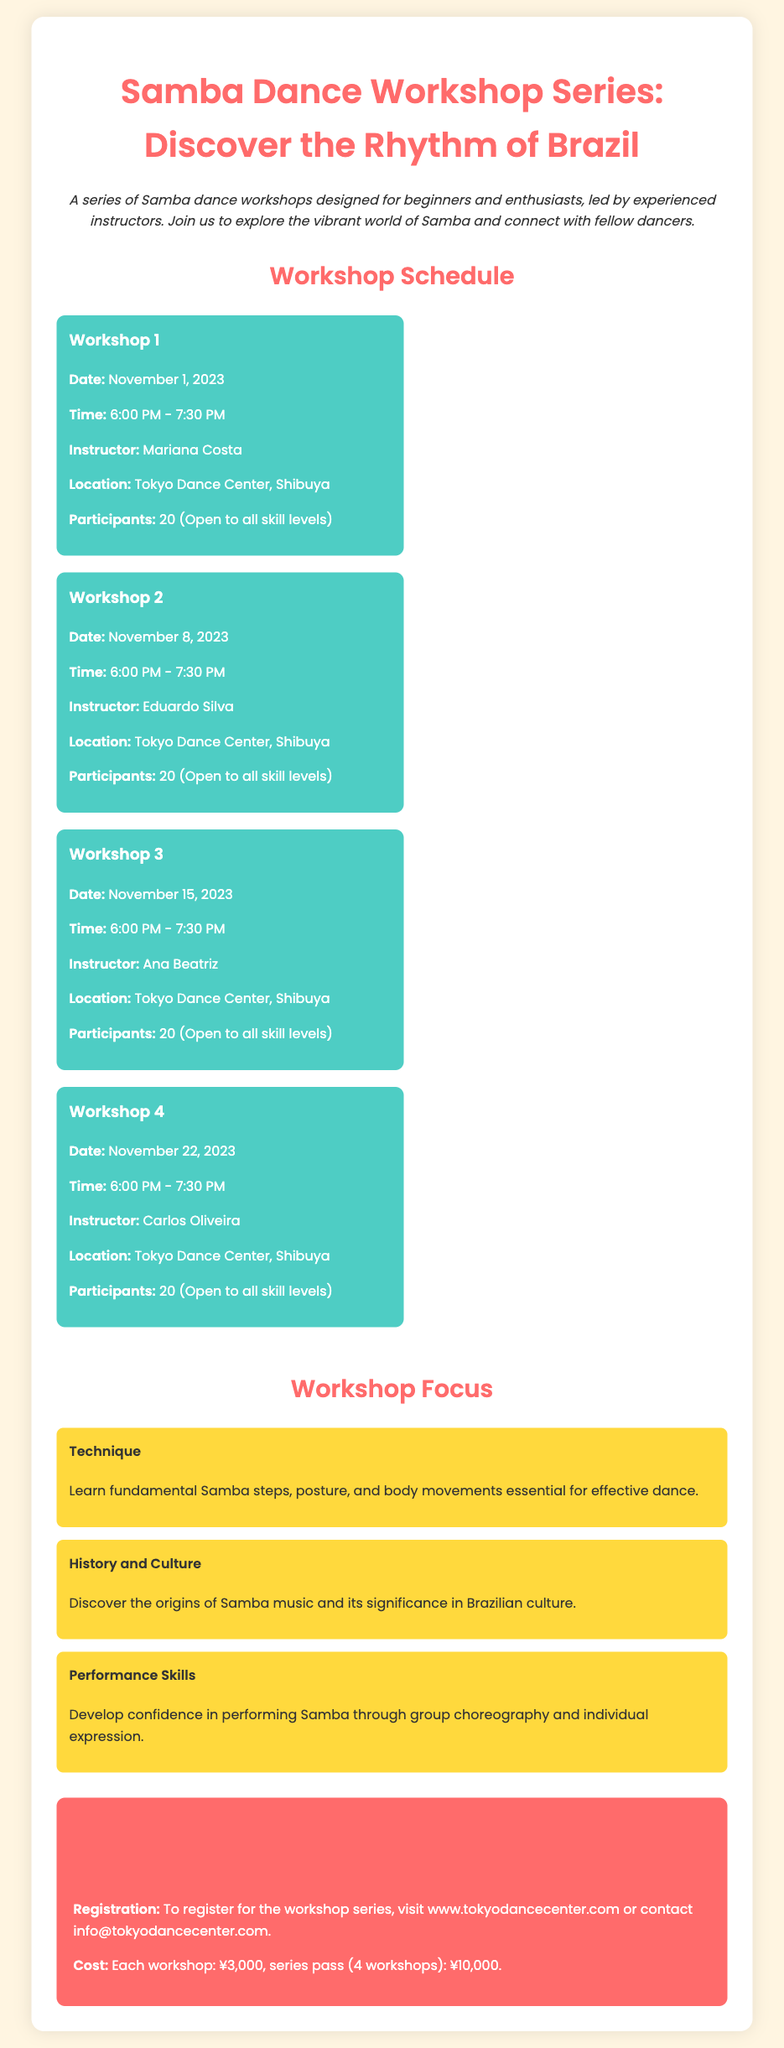What is the title of the workshop series? The title of the series is stated prominently at the beginning of the document.
Answer: Samba Dance Workshop Series: Discover the Rhythm of Brazil Who is the instructor for Workshop 2? The instructor for Workshop 2 is listed in the schedule section of the document.
Answer: Eduardo Silva How many participants can join each workshop? The document specifies the number of participants allowed for each workshop.
Answer: 20 What is the location of the workshops? The location is clearly mentioned in each workshop section of the document.
Answer: Tokyo Dance Center, Shibuya What is the cost of a single workshop? The cost for attending a single workshop is provided in the additional information section of the document.
Answer: ¥3,000 What is a focus item related to performance skills? A specific focus item is mentioned under the workshop focus section of the document.
Answer: Develop confidence in performing Samba through group choreography and individual expression On what date is Workshop 3 scheduled? The date for Workshop 3 is explicitly listed in the schedule section.
Answer: November 15, 2023 What is the total cost for the series pass? The total cost for the series pass is mentioned in the additional information section.
Answer: ¥10,000 When does Workshop 1 start? The start time for Workshop 1 is indicated in the schedule section of the document.
Answer: 6:00 PM 